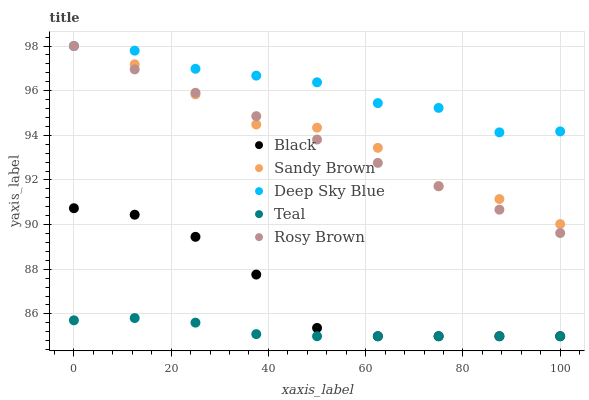Does Teal have the minimum area under the curve?
Answer yes or no. Yes. Does Deep Sky Blue have the maximum area under the curve?
Answer yes or no. Yes. Does Rosy Brown have the minimum area under the curve?
Answer yes or no. No. Does Rosy Brown have the maximum area under the curve?
Answer yes or no. No. Is Rosy Brown the smoothest?
Answer yes or no. Yes. Is Sandy Brown the roughest?
Answer yes or no. Yes. Is Black the smoothest?
Answer yes or no. No. Is Black the roughest?
Answer yes or no. No. Does Black have the lowest value?
Answer yes or no. Yes. Does Rosy Brown have the lowest value?
Answer yes or no. No. Does Deep Sky Blue have the highest value?
Answer yes or no. Yes. Does Black have the highest value?
Answer yes or no. No. Is Teal less than Rosy Brown?
Answer yes or no. Yes. Is Sandy Brown greater than Black?
Answer yes or no. Yes. Does Rosy Brown intersect Sandy Brown?
Answer yes or no. Yes. Is Rosy Brown less than Sandy Brown?
Answer yes or no. No. Is Rosy Brown greater than Sandy Brown?
Answer yes or no. No. Does Teal intersect Rosy Brown?
Answer yes or no. No. 